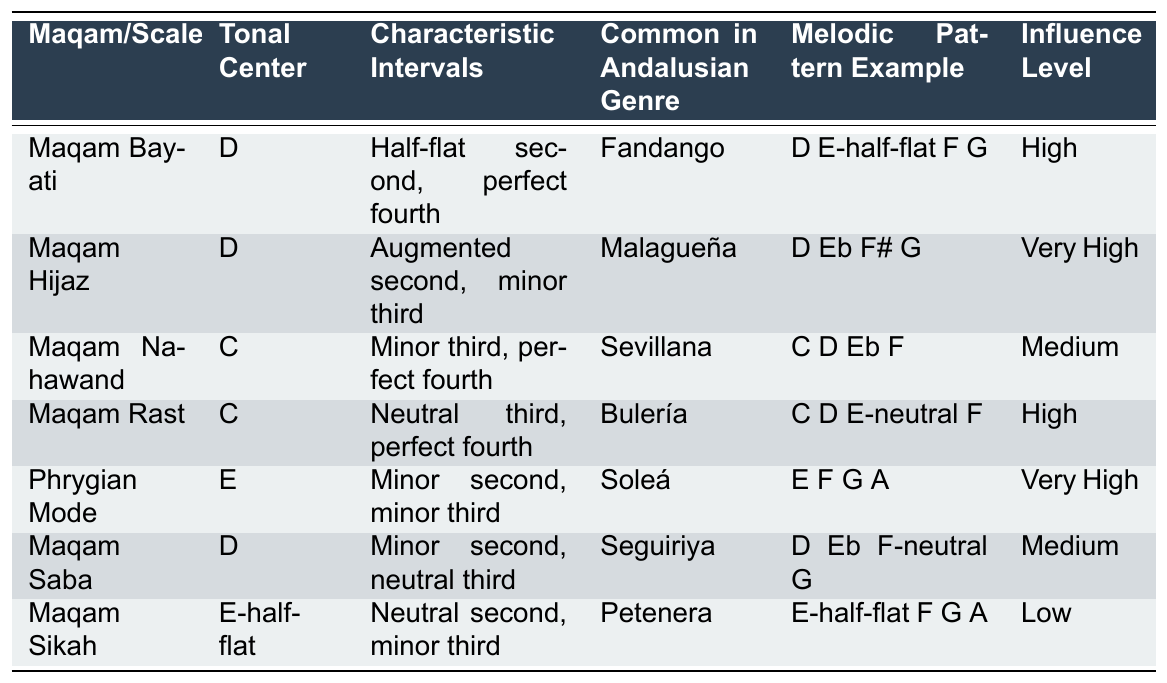What is the tonal center of Maqam Saba? By looking at the table under the "Tonal Center" column for Maqam Saba, we can see that it is listed as "D".
Answer: D Which melodic pattern example is associated with Maqam Hijaz? The "Melodic Pattern Example" column for Maqam Hijaz shows the pattern "D Eb F# G".
Answer: D Eb F# G How many maqams/scales have a high influence level? Counting the rows labeled with "High" in the "Influence Level" column, we find that there are 3 maqams (Maqam Bayati, Maqam Rast).
Answer: 3 Do any maqams have a tonal center of C and a "Very High" influence level? Checking the "Tonal Center" column for C, only Maqam Nahawand and Maqam Rast are present, but none of them have a "Very High" influence level. Therefore, the answer is no.
Answer: No Which maqam has the characteristic intervals of a perfect fourth and a minor third? Looking through the "Characteristic Intervals" column, only Maqam Nahawand has a perfect fourth but not with a minor third; hence there's no maqam with both specified intervals together.
Answer: None What is the common genre for Maqam Bayati? Referring to the "Common in Andalusian Genre" column, we see that Maqam Bayati is commonly found in "Fandango".
Answer: Fandango Is there any melodic pattern example listed for Maqam Sikah? The "Melodic Pattern Example" column includes "E-half-flat F G A" for Maqam Sikah, showing that there is indeed a listed melodic pattern.
Answer: Yes Which maqam has the lowest influence level and what is that level? Searching the "Influence Level" column, Maqam Sikah has the lowest influence level, which is categorized as "Low".
Answer: Low How many maqams are influenced at a medium level? By examining the "Influence Level" column, we find that there are 2 maqams (Maqam Nahawand and Maqam Saba) with a medium influence level.
Answer: 2 What are the characteristic intervals for Maqam Rast? The "Characteristic Intervals" column states that Maqam Rast has "Neutral third, perfect fourth".
Answer: Neutral third, perfect fourth 